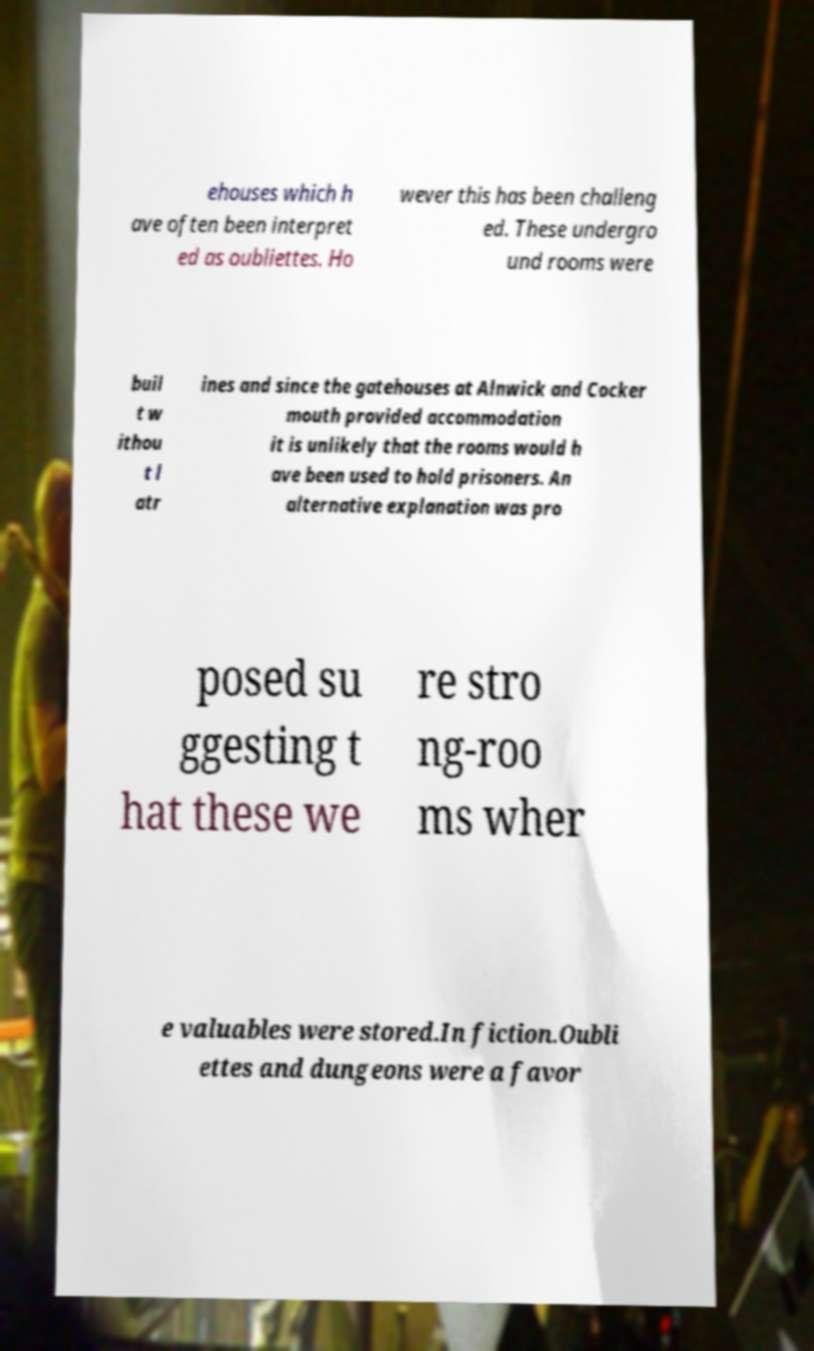I need the written content from this picture converted into text. Can you do that? ehouses which h ave often been interpret ed as oubliettes. Ho wever this has been challeng ed. These undergro und rooms were buil t w ithou t l atr ines and since the gatehouses at Alnwick and Cocker mouth provided accommodation it is unlikely that the rooms would h ave been used to hold prisoners. An alternative explanation was pro posed su ggesting t hat these we re stro ng-roo ms wher e valuables were stored.In fiction.Oubli ettes and dungeons were a favor 